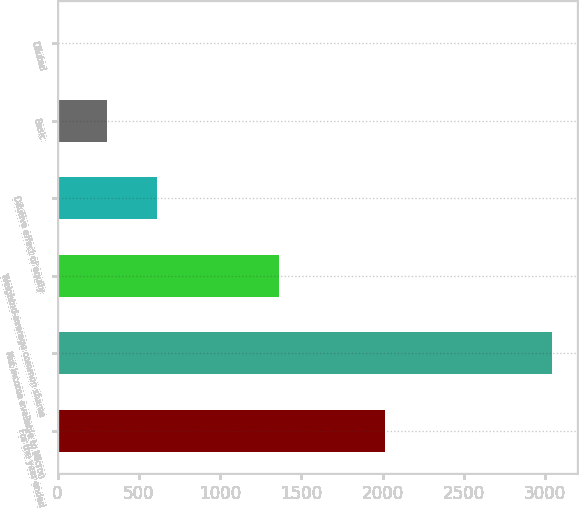Convert chart. <chart><loc_0><loc_0><loc_500><loc_500><bar_chart><fcel>For the year ended<fcel>Net income available to Micron<fcel>Weighted-average common shares<fcel>Dilutive effect of equity<fcel>Basic<fcel>Diluted<nl><fcel>2014<fcel>3043<fcel>1364.25<fcel>611.04<fcel>306.79<fcel>2.54<nl></chart> 